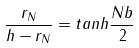Convert formula to latex. <formula><loc_0><loc_0><loc_500><loc_500>\frac { r _ { N } } { h - r _ { N } } = t a n h \frac { N b } { 2 }</formula> 